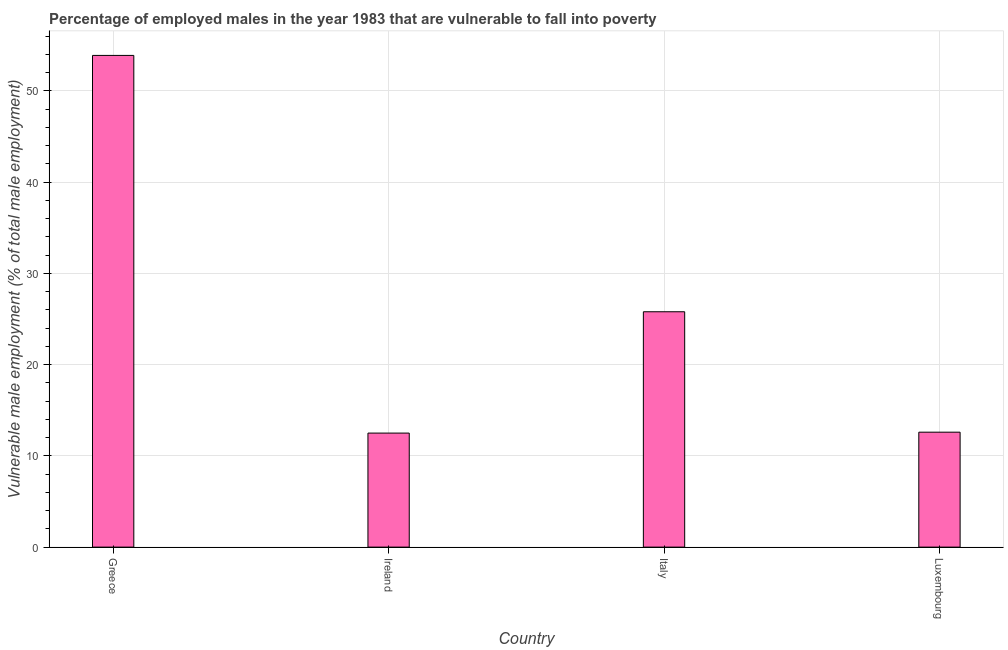Does the graph contain any zero values?
Provide a succinct answer. No. Does the graph contain grids?
Your response must be concise. Yes. What is the title of the graph?
Ensure brevity in your answer.  Percentage of employed males in the year 1983 that are vulnerable to fall into poverty. What is the label or title of the Y-axis?
Offer a terse response. Vulnerable male employment (% of total male employment). What is the percentage of employed males who are vulnerable to fall into poverty in Italy?
Ensure brevity in your answer.  25.8. Across all countries, what is the maximum percentage of employed males who are vulnerable to fall into poverty?
Provide a short and direct response. 53.9. Across all countries, what is the minimum percentage of employed males who are vulnerable to fall into poverty?
Your response must be concise. 12.5. In which country was the percentage of employed males who are vulnerable to fall into poverty maximum?
Offer a terse response. Greece. In which country was the percentage of employed males who are vulnerable to fall into poverty minimum?
Your response must be concise. Ireland. What is the sum of the percentage of employed males who are vulnerable to fall into poverty?
Give a very brief answer. 104.8. What is the difference between the percentage of employed males who are vulnerable to fall into poverty in Greece and Italy?
Make the answer very short. 28.1. What is the average percentage of employed males who are vulnerable to fall into poverty per country?
Provide a succinct answer. 26.2. What is the median percentage of employed males who are vulnerable to fall into poverty?
Offer a terse response. 19.2. What is the difference between the highest and the second highest percentage of employed males who are vulnerable to fall into poverty?
Your answer should be compact. 28.1. What is the difference between the highest and the lowest percentage of employed males who are vulnerable to fall into poverty?
Provide a succinct answer. 41.4. How many bars are there?
Your answer should be compact. 4. Are all the bars in the graph horizontal?
Offer a very short reply. No. What is the difference between two consecutive major ticks on the Y-axis?
Ensure brevity in your answer.  10. Are the values on the major ticks of Y-axis written in scientific E-notation?
Provide a succinct answer. No. What is the Vulnerable male employment (% of total male employment) of Greece?
Ensure brevity in your answer.  53.9. What is the Vulnerable male employment (% of total male employment) in Italy?
Provide a short and direct response. 25.8. What is the Vulnerable male employment (% of total male employment) in Luxembourg?
Provide a succinct answer. 12.6. What is the difference between the Vulnerable male employment (% of total male employment) in Greece and Ireland?
Keep it short and to the point. 41.4. What is the difference between the Vulnerable male employment (% of total male employment) in Greece and Italy?
Your response must be concise. 28.1. What is the difference between the Vulnerable male employment (% of total male employment) in Greece and Luxembourg?
Keep it short and to the point. 41.3. What is the difference between the Vulnerable male employment (% of total male employment) in Ireland and Italy?
Your answer should be very brief. -13.3. What is the difference between the Vulnerable male employment (% of total male employment) in Ireland and Luxembourg?
Your answer should be compact. -0.1. What is the difference between the Vulnerable male employment (% of total male employment) in Italy and Luxembourg?
Provide a succinct answer. 13.2. What is the ratio of the Vulnerable male employment (% of total male employment) in Greece to that in Ireland?
Offer a very short reply. 4.31. What is the ratio of the Vulnerable male employment (% of total male employment) in Greece to that in Italy?
Ensure brevity in your answer.  2.09. What is the ratio of the Vulnerable male employment (% of total male employment) in Greece to that in Luxembourg?
Your answer should be compact. 4.28. What is the ratio of the Vulnerable male employment (% of total male employment) in Ireland to that in Italy?
Ensure brevity in your answer.  0.48. What is the ratio of the Vulnerable male employment (% of total male employment) in Italy to that in Luxembourg?
Your response must be concise. 2.05. 